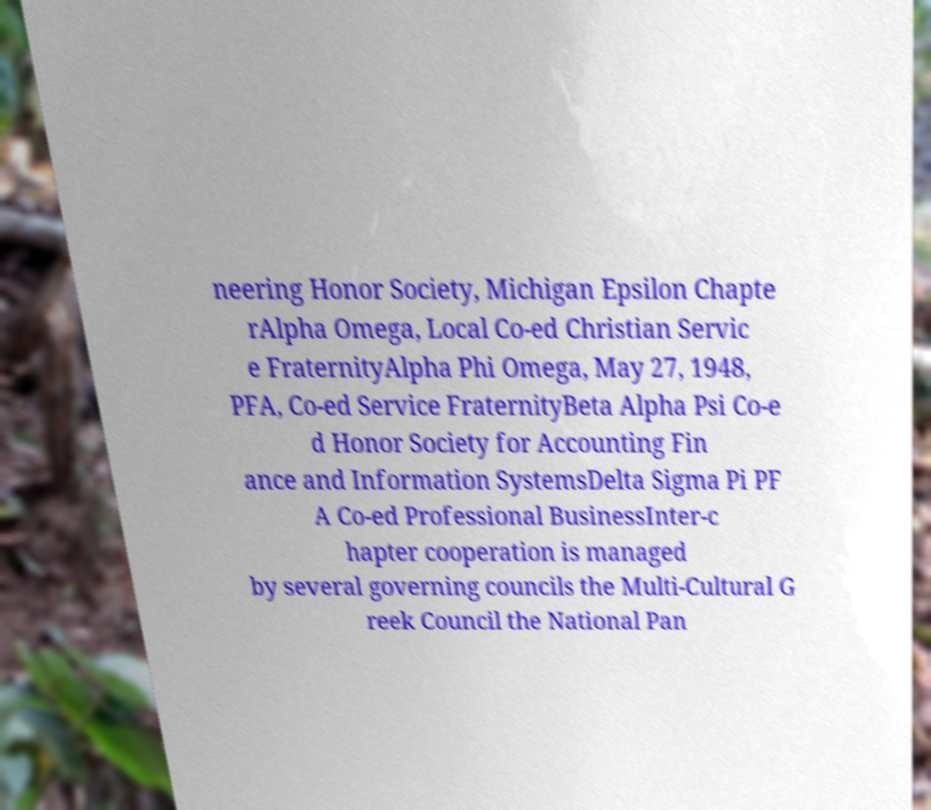There's text embedded in this image that I need extracted. Can you transcribe it verbatim? neering Honor Society, Michigan Epsilon Chapte rAlpha Omega, Local Co-ed Christian Servic e FraternityAlpha Phi Omega, May 27, 1948, PFA, Co-ed Service FraternityBeta Alpha Psi Co-e d Honor Society for Accounting Fin ance and Information SystemsDelta Sigma Pi PF A Co-ed Professional BusinessInter-c hapter cooperation is managed by several governing councils the Multi-Cultural G reek Council the National Pan 